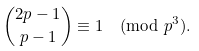<formula> <loc_0><loc_0><loc_500><loc_500>\binom { 2 p - 1 } { p - 1 } \equiv 1 \pmod { p ^ { 3 } } .</formula> 